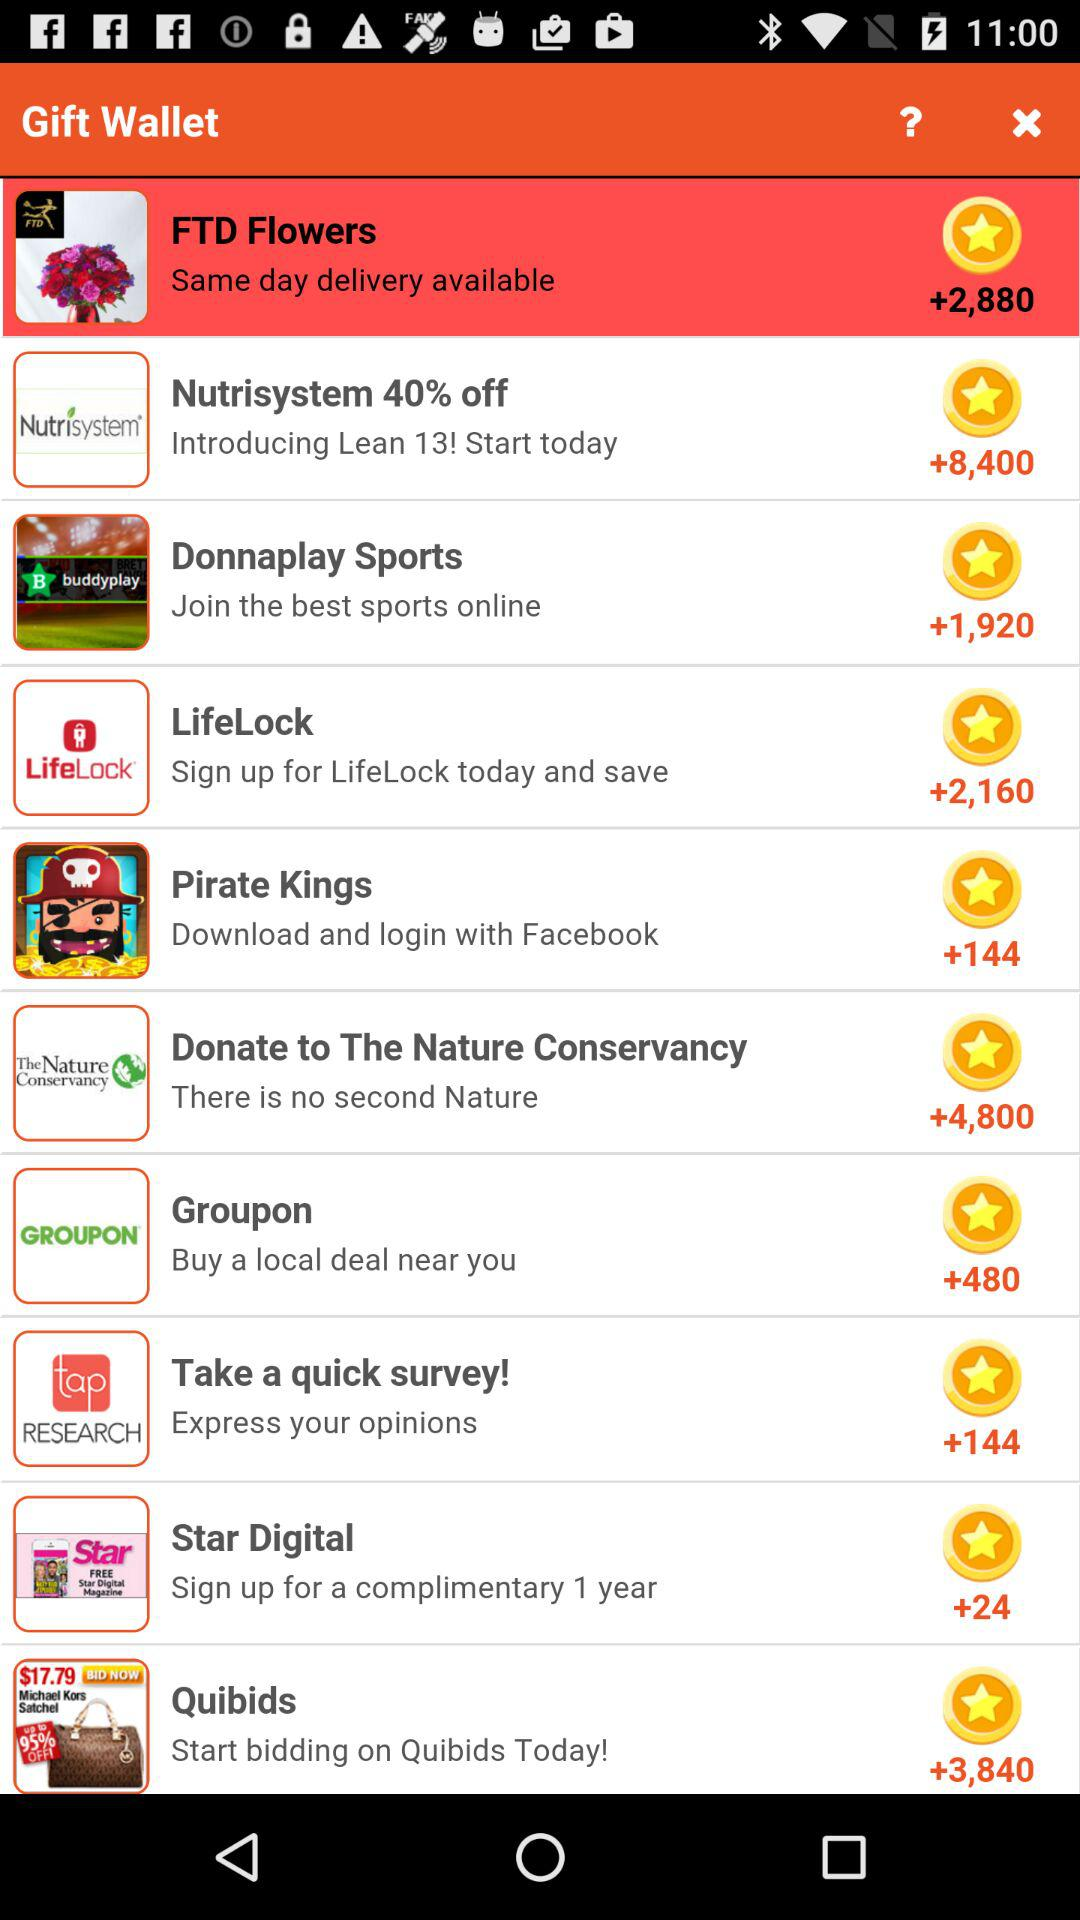144 points are for which gift? There are 144 points for "Pirate Kings" and "Take a quick survey!". 